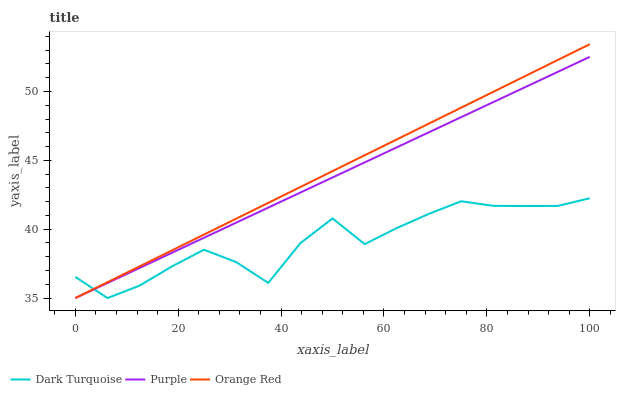Does Dark Turquoise have the minimum area under the curve?
Answer yes or no. Yes. Does Orange Red have the maximum area under the curve?
Answer yes or no. Yes. Does Orange Red have the minimum area under the curve?
Answer yes or no. No. Does Dark Turquoise have the maximum area under the curve?
Answer yes or no. No. Is Orange Red the smoothest?
Answer yes or no. Yes. Is Dark Turquoise the roughest?
Answer yes or no. Yes. Is Dark Turquoise the smoothest?
Answer yes or no. No. Is Orange Red the roughest?
Answer yes or no. No. Does Purple have the lowest value?
Answer yes or no. Yes. Does Orange Red have the highest value?
Answer yes or no. Yes. Does Dark Turquoise have the highest value?
Answer yes or no. No. Does Orange Red intersect Purple?
Answer yes or no. Yes. Is Orange Red less than Purple?
Answer yes or no. No. Is Orange Red greater than Purple?
Answer yes or no. No. 